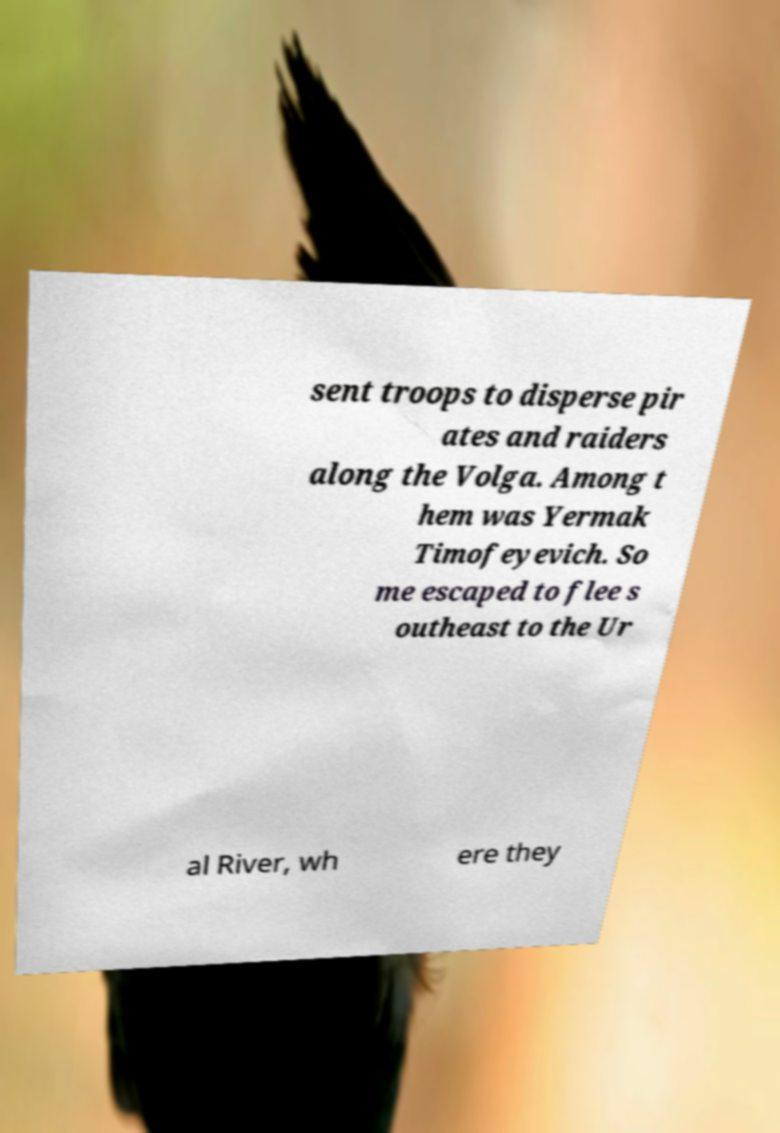Could you assist in decoding the text presented in this image and type it out clearly? sent troops to disperse pir ates and raiders along the Volga. Among t hem was Yermak Timofeyevich. So me escaped to flee s outheast to the Ur al River, wh ere they 